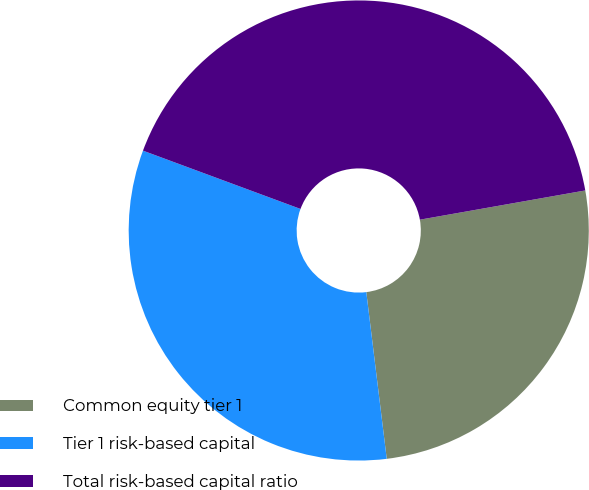<chart> <loc_0><loc_0><loc_500><loc_500><pie_chart><fcel>Common equity tier 1<fcel>Tier 1 risk-based capital<fcel>Total risk-based capital ratio<nl><fcel>25.84%<fcel>32.58%<fcel>41.57%<nl></chart> 